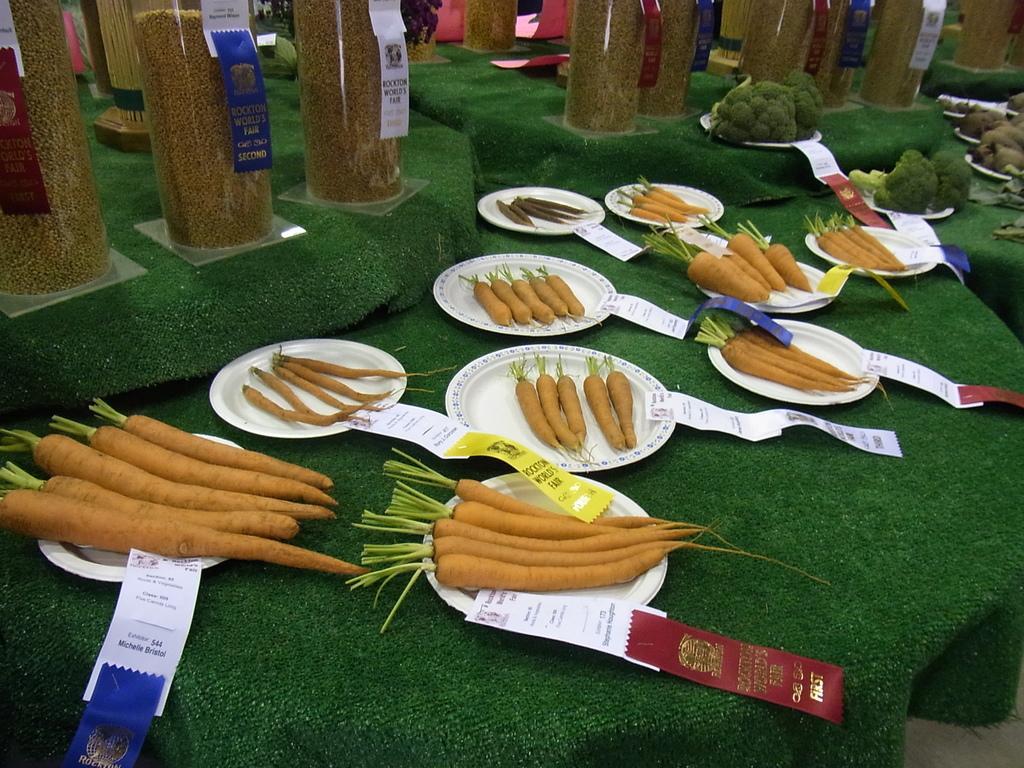Could you give a brief overview of what you see in this image? There are carrots arranged on the white color plates, along with the slips on the table which is covered with green color carpet. In the background, there are other objects placed on the tables, which are covered with green color carpet. 